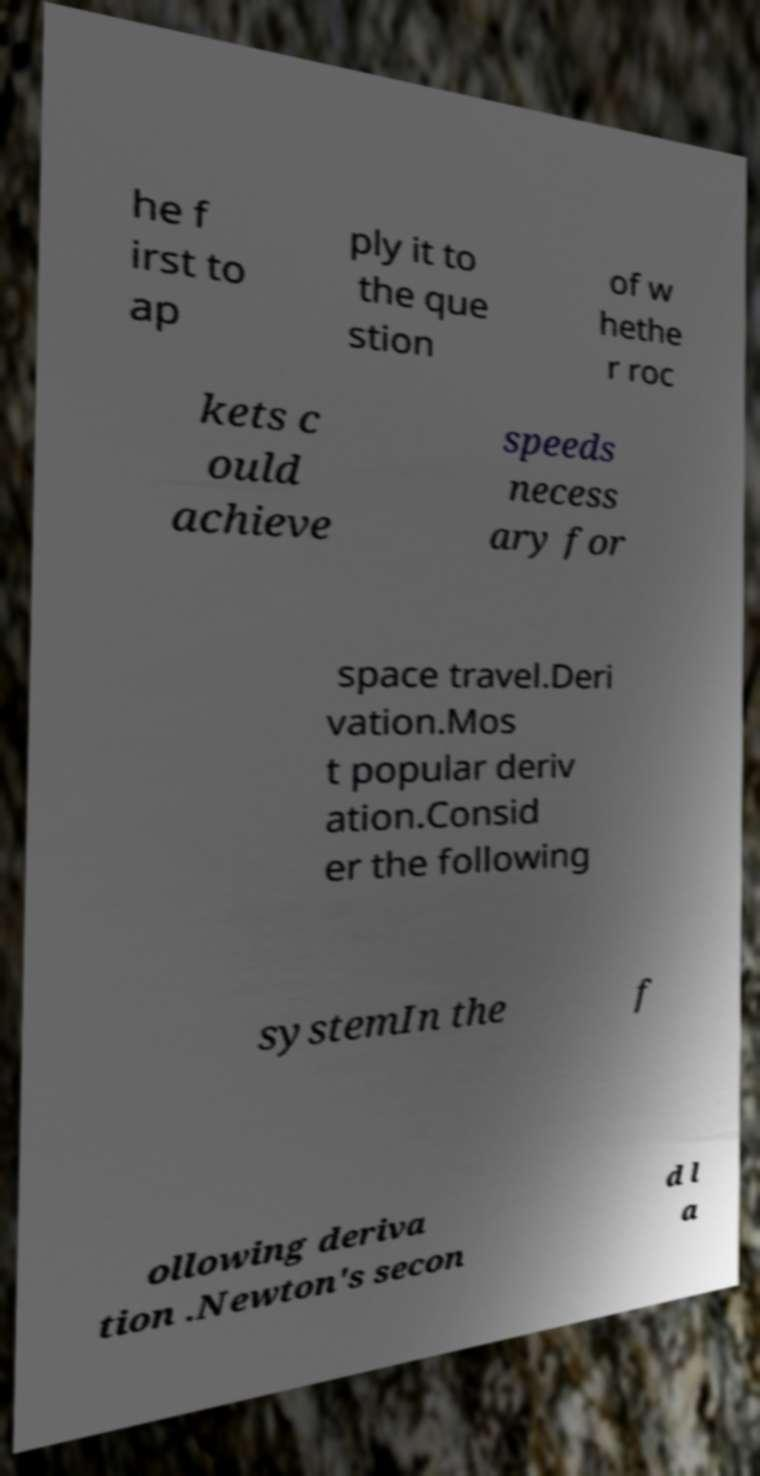What messages or text are displayed in this image? I need them in a readable, typed format. he f irst to ap ply it to the que stion of w hethe r roc kets c ould achieve speeds necess ary for space travel.Deri vation.Mos t popular deriv ation.Consid er the following systemIn the f ollowing deriva tion .Newton's secon d l a 